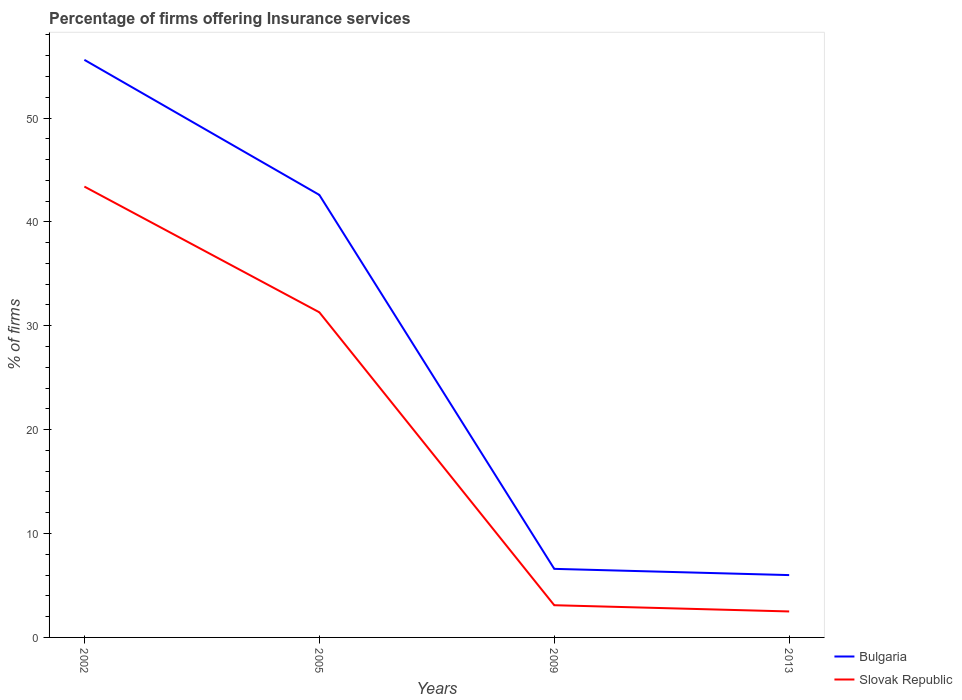Does the line corresponding to Bulgaria intersect with the line corresponding to Slovak Republic?
Offer a very short reply. No. What is the total percentage of firms offering insurance services in Slovak Republic in the graph?
Ensure brevity in your answer.  40.9. What is the difference between the highest and the second highest percentage of firms offering insurance services in Slovak Republic?
Provide a short and direct response. 40.9. What is the difference between the highest and the lowest percentage of firms offering insurance services in Slovak Republic?
Provide a succinct answer. 2. How many lines are there?
Provide a succinct answer. 2. How many years are there in the graph?
Your answer should be very brief. 4. Does the graph contain any zero values?
Provide a succinct answer. No. Does the graph contain grids?
Offer a very short reply. No. Where does the legend appear in the graph?
Ensure brevity in your answer.  Bottom right. How many legend labels are there?
Provide a succinct answer. 2. How are the legend labels stacked?
Offer a very short reply. Vertical. What is the title of the graph?
Keep it short and to the point. Percentage of firms offering Insurance services. Does "Switzerland" appear as one of the legend labels in the graph?
Make the answer very short. No. What is the label or title of the Y-axis?
Ensure brevity in your answer.  % of firms. What is the % of firms of Bulgaria in 2002?
Provide a succinct answer. 55.6. What is the % of firms of Slovak Republic in 2002?
Make the answer very short. 43.4. What is the % of firms of Bulgaria in 2005?
Your response must be concise. 42.6. What is the % of firms of Slovak Republic in 2005?
Your answer should be compact. 31.3. What is the % of firms of Bulgaria in 2013?
Your answer should be very brief. 6. Across all years, what is the maximum % of firms of Bulgaria?
Offer a terse response. 55.6. Across all years, what is the maximum % of firms of Slovak Republic?
Offer a terse response. 43.4. Across all years, what is the minimum % of firms of Bulgaria?
Your response must be concise. 6. Across all years, what is the minimum % of firms in Slovak Republic?
Your answer should be very brief. 2.5. What is the total % of firms in Bulgaria in the graph?
Your answer should be very brief. 110.8. What is the total % of firms in Slovak Republic in the graph?
Offer a terse response. 80.3. What is the difference between the % of firms in Bulgaria in 2002 and that in 2005?
Keep it short and to the point. 13. What is the difference between the % of firms of Slovak Republic in 2002 and that in 2009?
Keep it short and to the point. 40.3. What is the difference between the % of firms of Bulgaria in 2002 and that in 2013?
Provide a succinct answer. 49.6. What is the difference between the % of firms of Slovak Republic in 2002 and that in 2013?
Give a very brief answer. 40.9. What is the difference between the % of firms in Slovak Republic in 2005 and that in 2009?
Keep it short and to the point. 28.2. What is the difference between the % of firms of Bulgaria in 2005 and that in 2013?
Ensure brevity in your answer.  36.6. What is the difference between the % of firms in Slovak Republic in 2005 and that in 2013?
Make the answer very short. 28.8. What is the difference between the % of firms of Bulgaria in 2002 and the % of firms of Slovak Republic in 2005?
Provide a succinct answer. 24.3. What is the difference between the % of firms in Bulgaria in 2002 and the % of firms in Slovak Republic in 2009?
Ensure brevity in your answer.  52.5. What is the difference between the % of firms in Bulgaria in 2002 and the % of firms in Slovak Republic in 2013?
Make the answer very short. 53.1. What is the difference between the % of firms in Bulgaria in 2005 and the % of firms in Slovak Republic in 2009?
Your answer should be very brief. 39.5. What is the difference between the % of firms of Bulgaria in 2005 and the % of firms of Slovak Republic in 2013?
Keep it short and to the point. 40.1. What is the average % of firms in Bulgaria per year?
Your answer should be compact. 27.7. What is the average % of firms in Slovak Republic per year?
Provide a succinct answer. 20.07. In the year 2002, what is the difference between the % of firms in Bulgaria and % of firms in Slovak Republic?
Provide a succinct answer. 12.2. In the year 2009, what is the difference between the % of firms in Bulgaria and % of firms in Slovak Republic?
Your answer should be compact. 3.5. In the year 2013, what is the difference between the % of firms in Bulgaria and % of firms in Slovak Republic?
Your answer should be very brief. 3.5. What is the ratio of the % of firms in Bulgaria in 2002 to that in 2005?
Ensure brevity in your answer.  1.31. What is the ratio of the % of firms in Slovak Republic in 2002 to that in 2005?
Provide a short and direct response. 1.39. What is the ratio of the % of firms of Bulgaria in 2002 to that in 2009?
Your response must be concise. 8.42. What is the ratio of the % of firms in Slovak Republic in 2002 to that in 2009?
Keep it short and to the point. 14. What is the ratio of the % of firms of Bulgaria in 2002 to that in 2013?
Make the answer very short. 9.27. What is the ratio of the % of firms in Slovak Republic in 2002 to that in 2013?
Your response must be concise. 17.36. What is the ratio of the % of firms in Bulgaria in 2005 to that in 2009?
Your response must be concise. 6.45. What is the ratio of the % of firms of Slovak Republic in 2005 to that in 2009?
Ensure brevity in your answer.  10.1. What is the ratio of the % of firms of Slovak Republic in 2005 to that in 2013?
Ensure brevity in your answer.  12.52. What is the ratio of the % of firms of Bulgaria in 2009 to that in 2013?
Provide a short and direct response. 1.1. What is the ratio of the % of firms in Slovak Republic in 2009 to that in 2013?
Your answer should be very brief. 1.24. What is the difference between the highest and the second highest % of firms in Bulgaria?
Your response must be concise. 13. What is the difference between the highest and the second highest % of firms of Slovak Republic?
Ensure brevity in your answer.  12.1. What is the difference between the highest and the lowest % of firms of Bulgaria?
Your response must be concise. 49.6. What is the difference between the highest and the lowest % of firms of Slovak Republic?
Keep it short and to the point. 40.9. 